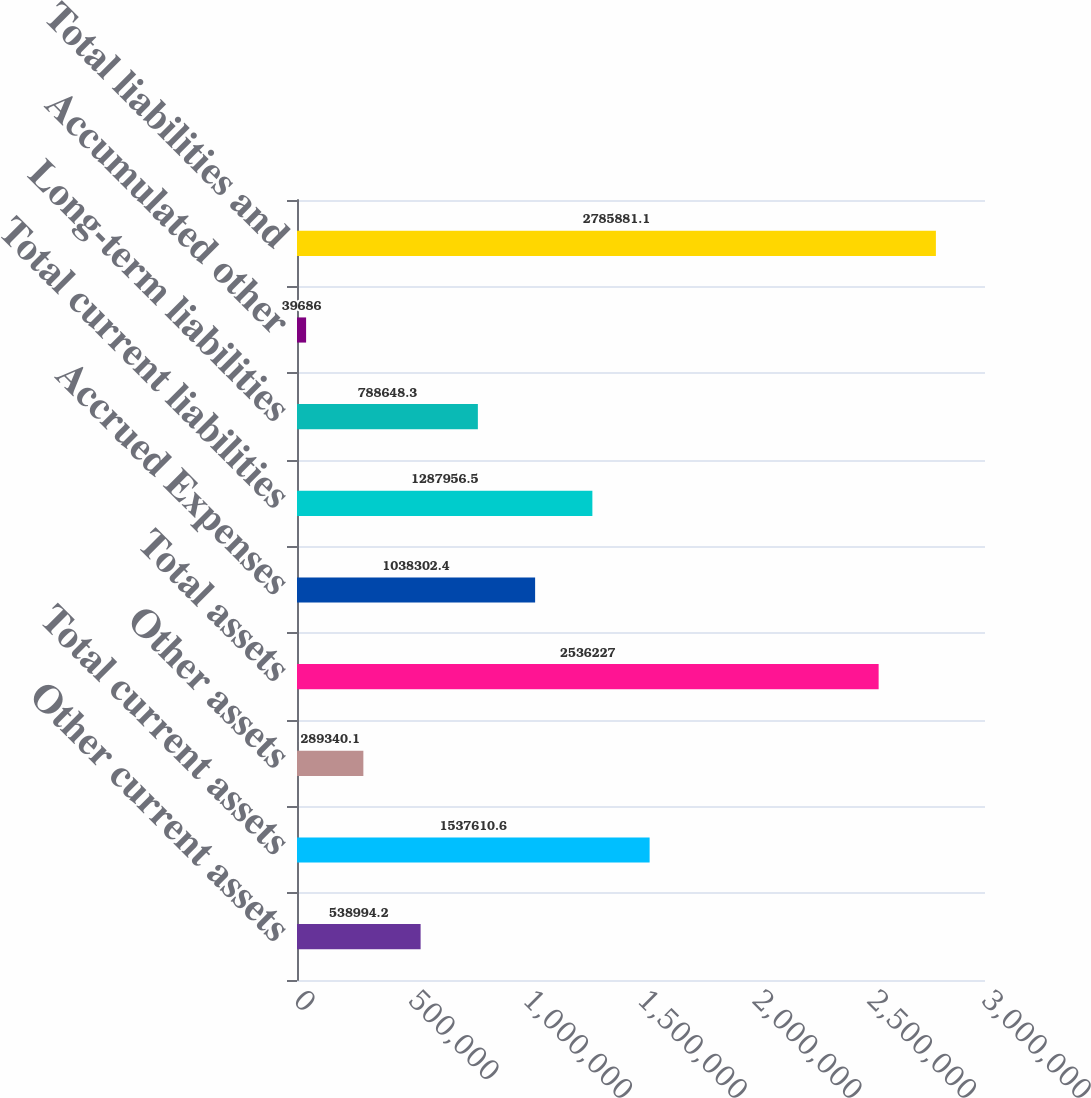Convert chart to OTSL. <chart><loc_0><loc_0><loc_500><loc_500><bar_chart><fcel>Other current assets<fcel>Total current assets<fcel>Other assets<fcel>Total assets<fcel>Accrued Expenses<fcel>Total current liabilities<fcel>Long-term liabilities<fcel>Accumulated other<fcel>Total liabilities and<nl><fcel>538994<fcel>1.53761e+06<fcel>289340<fcel>2.53623e+06<fcel>1.0383e+06<fcel>1.28796e+06<fcel>788648<fcel>39686<fcel>2.78588e+06<nl></chart> 